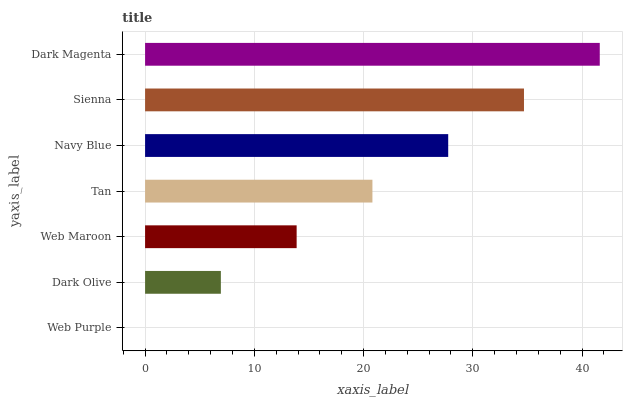Is Web Purple the minimum?
Answer yes or no. Yes. Is Dark Magenta the maximum?
Answer yes or no. Yes. Is Dark Olive the minimum?
Answer yes or no. No. Is Dark Olive the maximum?
Answer yes or no. No. Is Dark Olive greater than Web Purple?
Answer yes or no. Yes. Is Web Purple less than Dark Olive?
Answer yes or no. Yes. Is Web Purple greater than Dark Olive?
Answer yes or no. No. Is Dark Olive less than Web Purple?
Answer yes or no. No. Is Tan the high median?
Answer yes or no. Yes. Is Tan the low median?
Answer yes or no. Yes. Is Navy Blue the high median?
Answer yes or no. No. Is Web Maroon the low median?
Answer yes or no. No. 